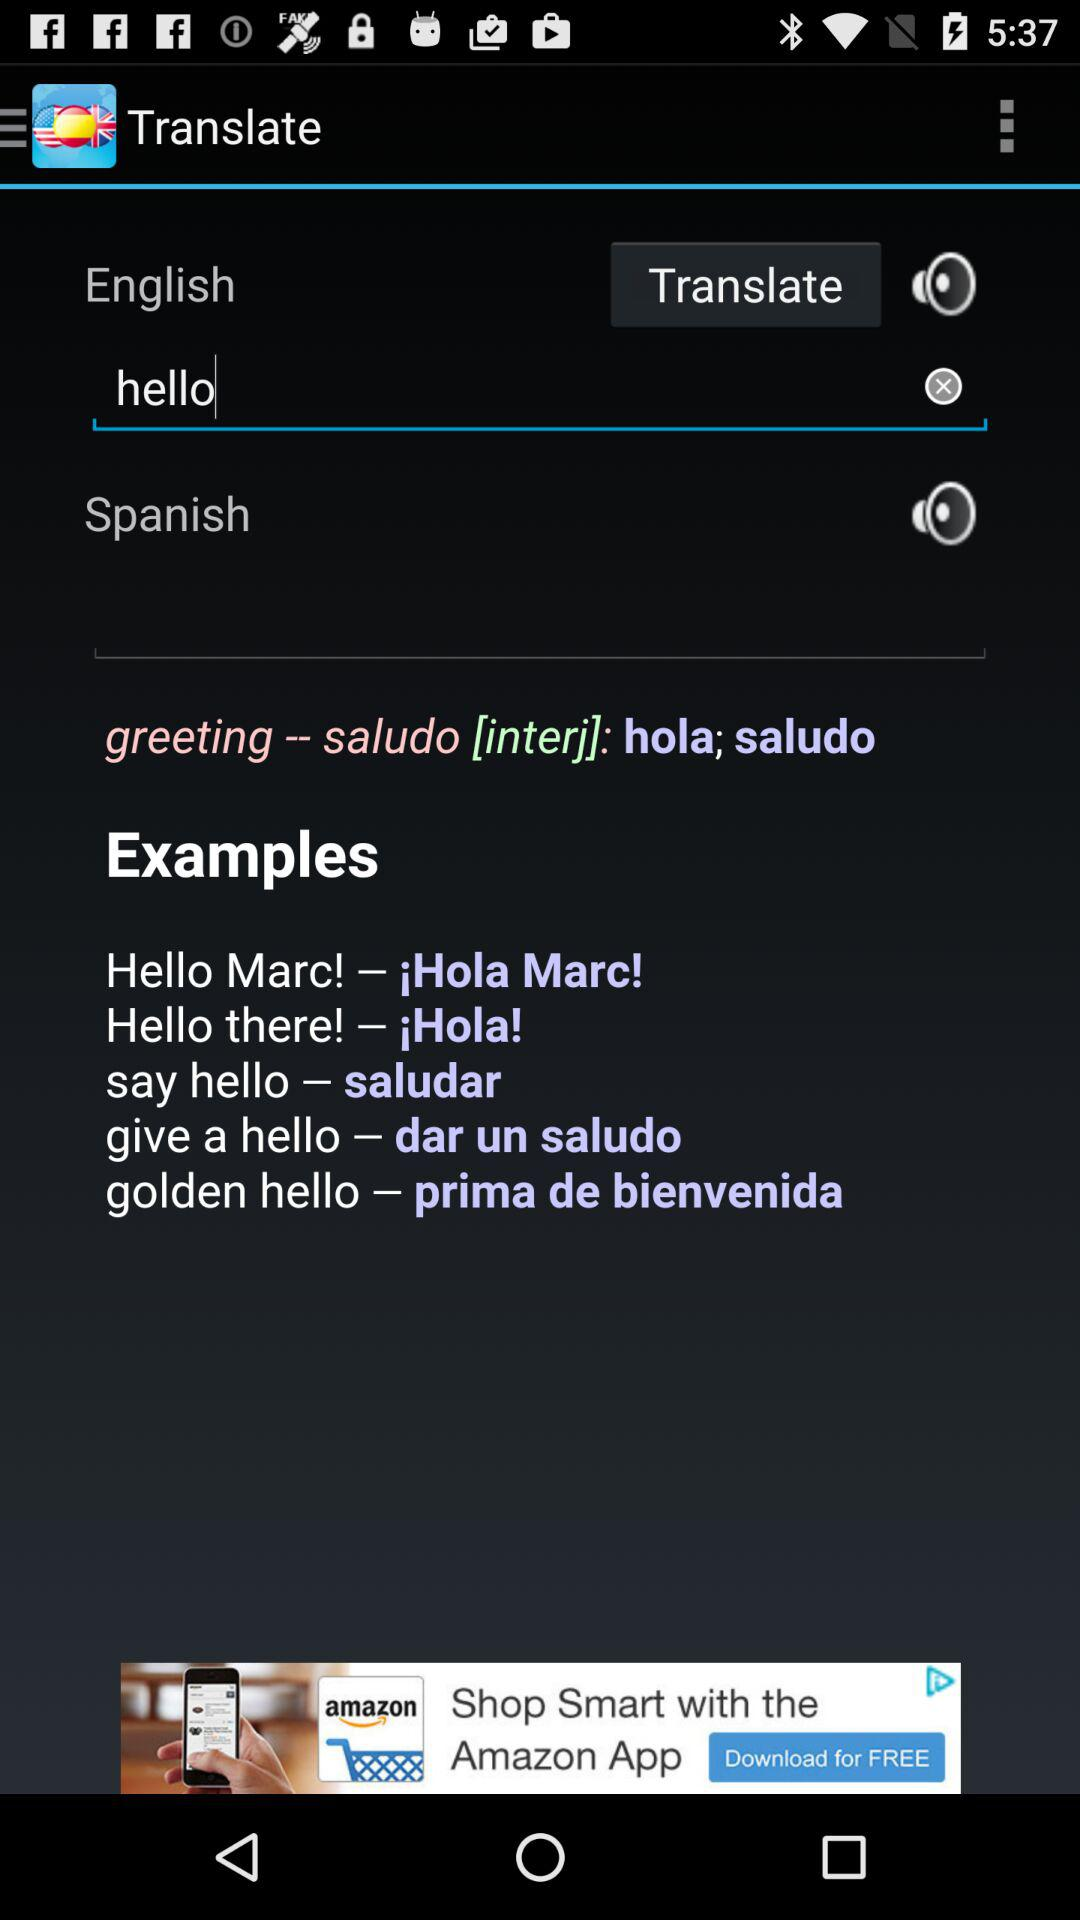What is the word for which the person wants a translation? The word for which the person wants a translation is "hello". 